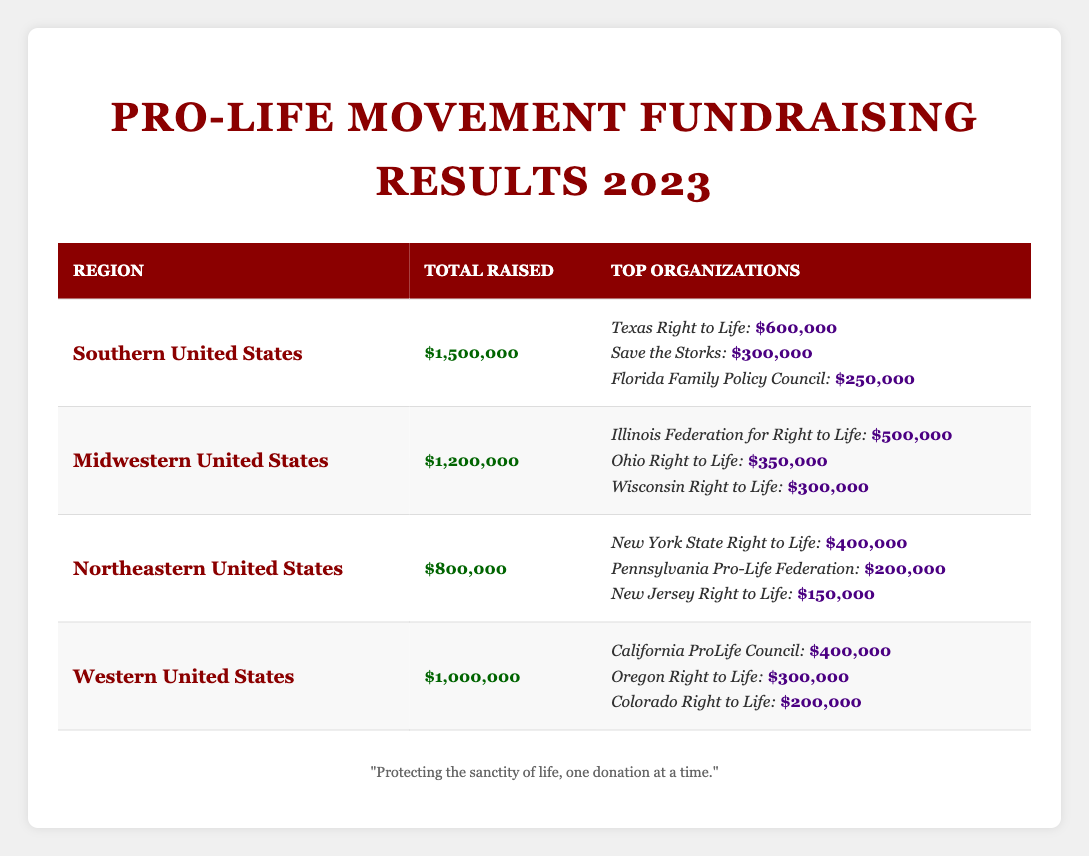What is the total amount raised by the Southern United States region? According to the table, the Southern United States raised a total of $1,500,000, as directly listed in the total raised column for that region.
Answer: $1,500,000 Which organization raised the most funds in the Midwestern United States? The table lists the Illinois Federation for Right to Life as the top organization in the Midwestern United States with an amount raised of $500,000, which is higher than the amounts raised by any other organization in that region.
Answer: Illinois Federation for Right to Life How much total fundraising did the Northeastern United States region achieve? The total fundraising amount for the Northeastern United States is shown as $800,000 in the total raised column for that region.
Answer: $800,000 What are the top three organizations fundraising in the Southern United States, by amount raised? According to the table, the top three organizations in the Southern United States are Texas Right to Life ($600,000), Save the Storks ($300,000), and Florida Family Policy Council ($250,000), as reflected in the top organizations listed for that region.
Answer: Texas Right to Life, Save the Storks, Florida Family Policy Council Which region raised the least total funds in 2023 among the listed regions? By comparing the total raised amounts for each region, the Northeastern United States raised the least amount at $800,000, while the Southern United States raised the most at $1,500,000.
Answer: Northeastern United States What is the difference in total funds raised between the Southern and Western United States? The Southern United States raised $1,500,000 and the Western United States raised $1,000,000. The difference is found by subtracting the two: $1,500,000 - $1,000,000 = $500,000.
Answer: $500,000 What are the total amounts raised by the two top organizations in the Western United States? The top two organizations in the Western United States are California ProLife Council ($400,000) and Oregon Right to Life ($300,000). To find the total, you add these amounts: $400,000 + $300,000 = $700,000.
Answer: $700,000 True or False: Save the Storks raised more than Ohio Right to Life. Upon examining the data, Save the Storks raised $300,000, while Ohio Right to Life raised $350,000. Thus, Save the Storks did not raise more than Ohio Right to Life, making this statement false.
Answer: False Which region raised more than $1 million in total, and by how much? The Southern United States region raised $1,500,000 and the Midwestern United States raised $1,200,000, both exceeding $1 million. The Southern United States exceeds by $500,000 while the Midwestern exceeds by $200,000 over the million mark.
Answer: Southern ($500,000); Midwestern ($200,000) How much funding was raised in total across all regions? The total can be found by adding the amounts raised in each region: $1,500,000 (Southern) + $1,200,000 (Midwestern) + $800,000 (Northeastern) + $1,000,000 (Western) = $4,500,000.
Answer: $4,500,000 